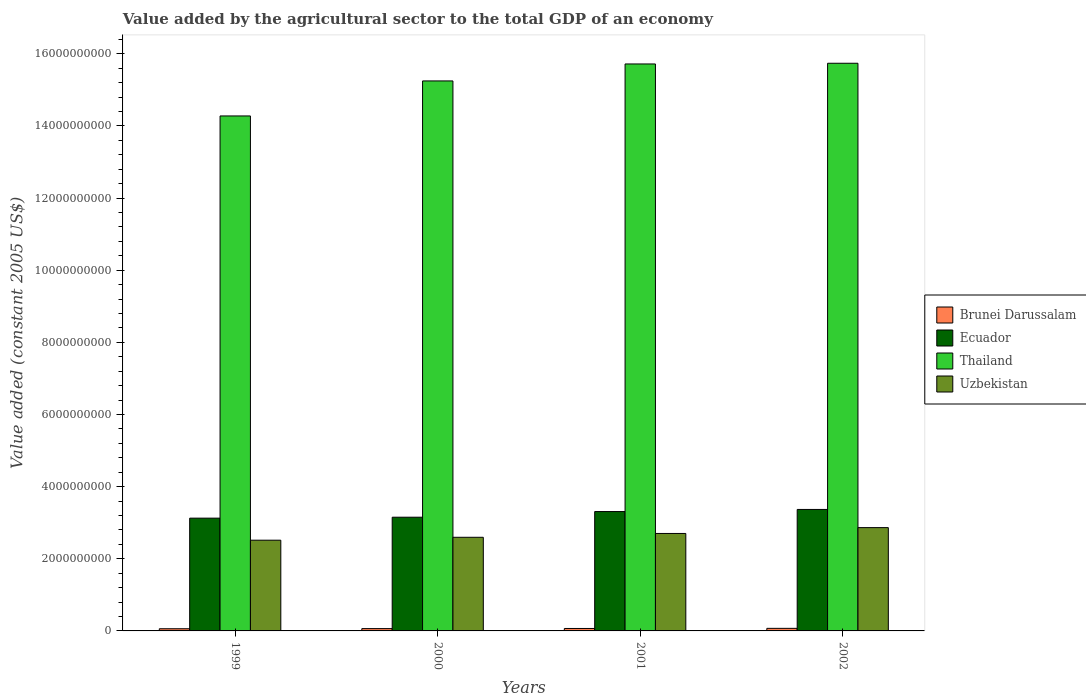How many groups of bars are there?
Make the answer very short. 4. Are the number of bars on each tick of the X-axis equal?
Give a very brief answer. Yes. How many bars are there on the 1st tick from the left?
Provide a succinct answer. 4. How many bars are there on the 2nd tick from the right?
Keep it short and to the point. 4. What is the value added by the agricultural sector in Thailand in 1999?
Give a very brief answer. 1.43e+1. Across all years, what is the maximum value added by the agricultural sector in Thailand?
Ensure brevity in your answer.  1.57e+1. Across all years, what is the minimum value added by the agricultural sector in Ecuador?
Your response must be concise. 3.13e+09. In which year was the value added by the agricultural sector in Uzbekistan maximum?
Ensure brevity in your answer.  2002. What is the total value added by the agricultural sector in Uzbekistan in the graph?
Give a very brief answer. 1.07e+1. What is the difference between the value added by the agricultural sector in Thailand in 2001 and that in 2002?
Your answer should be very brief. -1.94e+07. What is the difference between the value added by the agricultural sector in Brunei Darussalam in 2000 and the value added by the agricultural sector in Uzbekistan in 2001?
Make the answer very short. -2.64e+09. What is the average value added by the agricultural sector in Thailand per year?
Give a very brief answer. 1.52e+1. In the year 2002, what is the difference between the value added by the agricultural sector in Ecuador and value added by the agricultural sector in Brunei Darussalam?
Offer a very short reply. 3.30e+09. What is the ratio of the value added by the agricultural sector in Uzbekistan in 1999 to that in 2002?
Keep it short and to the point. 0.88. Is the value added by the agricultural sector in Brunei Darussalam in 2001 less than that in 2002?
Give a very brief answer. Yes. Is the difference between the value added by the agricultural sector in Ecuador in 2000 and 2002 greater than the difference between the value added by the agricultural sector in Brunei Darussalam in 2000 and 2002?
Make the answer very short. No. What is the difference between the highest and the second highest value added by the agricultural sector in Thailand?
Your answer should be very brief. 1.94e+07. What is the difference between the highest and the lowest value added by the agricultural sector in Thailand?
Your response must be concise. 1.46e+09. In how many years, is the value added by the agricultural sector in Brunei Darussalam greater than the average value added by the agricultural sector in Brunei Darussalam taken over all years?
Your response must be concise. 2. Is the sum of the value added by the agricultural sector in Thailand in 1999 and 2002 greater than the maximum value added by the agricultural sector in Brunei Darussalam across all years?
Offer a very short reply. Yes. What does the 2nd bar from the left in 1999 represents?
Provide a short and direct response. Ecuador. What does the 4th bar from the right in 2000 represents?
Make the answer very short. Brunei Darussalam. Is it the case that in every year, the sum of the value added by the agricultural sector in Brunei Darussalam and value added by the agricultural sector in Thailand is greater than the value added by the agricultural sector in Ecuador?
Your response must be concise. Yes. How many bars are there?
Provide a short and direct response. 16. Are all the bars in the graph horizontal?
Your answer should be compact. No. How many years are there in the graph?
Provide a succinct answer. 4. Does the graph contain grids?
Your response must be concise. No. Where does the legend appear in the graph?
Provide a short and direct response. Center right. How are the legend labels stacked?
Offer a terse response. Vertical. What is the title of the graph?
Provide a short and direct response. Value added by the agricultural sector to the total GDP of an economy. What is the label or title of the X-axis?
Keep it short and to the point. Years. What is the label or title of the Y-axis?
Your response must be concise. Value added (constant 2005 US$). What is the Value added (constant 2005 US$) of Brunei Darussalam in 1999?
Offer a very short reply. 6.02e+07. What is the Value added (constant 2005 US$) in Ecuador in 1999?
Keep it short and to the point. 3.13e+09. What is the Value added (constant 2005 US$) in Thailand in 1999?
Give a very brief answer. 1.43e+1. What is the Value added (constant 2005 US$) in Uzbekistan in 1999?
Your answer should be compact. 2.52e+09. What is the Value added (constant 2005 US$) of Brunei Darussalam in 2000?
Provide a short and direct response. 6.42e+07. What is the Value added (constant 2005 US$) of Ecuador in 2000?
Offer a terse response. 3.15e+09. What is the Value added (constant 2005 US$) of Thailand in 2000?
Your answer should be compact. 1.52e+1. What is the Value added (constant 2005 US$) of Uzbekistan in 2000?
Provide a short and direct response. 2.60e+09. What is the Value added (constant 2005 US$) of Brunei Darussalam in 2001?
Make the answer very short. 6.79e+07. What is the Value added (constant 2005 US$) in Ecuador in 2001?
Offer a very short reply. 3.31e+09. What is the Value added (constant 2005 US$) in Thailand in 2001?
Give a very brief answer. 1.57e+1. What is the Value added (constant 2005 US$) in Uzbekistan in 2001?
Give a very brief answer. 2.70e+09. What is the Value added (constant 2005 US$) of Brunei Darussalam in 2002?
Give a very brief answer. 7.14e+07. What is the Value added (constant 2005 US$) in Ecuador in 2002?
Your answer should be very brief. 3.37e+09. What is the Value added (constant 2005 US$) in Thailand in 2002?
Your answer should be compact. 1.57e+1. What is the Value added (constant 2005 US$) of Uzbekistan in 2002?
Provide a succinct answer. 2.86e+09. Across all years, what is the maximum Value added (constant 2005 US$) of Brunei Darussalam?
Keep it short and to the point. 7.14e+07. Across all years, what is the maximum Value added (constant 2005 US$) in Ecuador?
Your answer should be compact. 3.37e+09. Across all years, what is the maximum Value added (constant 2005 US$) in Thailand?
Make the answer very short. 1.57e+1. Across all years, what is the maximum Value added (constant 2005 US$) in Uzbekistan?
Give a very brief answer. 2.86e+09. Across all years, what is the minimum Value added (constant 2005 US$) in Brunei Darussalam?
Provide a succinct answer. 6.02e+07. Across all years, what is the minimum Value added (constant 2005 US$) of Ecuador?
Ensure brevity in your answer.  3.13e+09. Across all years, what is the minimum Value added (constant 2005 US$) in Thailand?
Give a very brief answer. 1.43e+1. Across all years, what is the minimum Value added (constant 2005 US$) in Uzbekistan?
Offer a terse response. 2.52e+09. What is the total Value added (constant 2005 US$) in Brunei Darussalam in the graph?
Keep it short and to the point. 2.64e+08. What is the total Value added (constant 2005 US$) of Ecuador in the graph?
Your answer should be very brief. 1.30e+1. What is the total Value added (constant 2005 US$) in Thailand in the graph?
Offer a terse response. 6.10e+1. What is the total Value added (constant 2005 US$) in Uzbekistan in the graph?
Offer a very short reply. 1.07e+1. What is the difference between the Value added (constant 2005 US$) in Brunei Darussalam in 1999 and that in 2000?
Your answer should be very brief. -3.95e+06. What is the difference between the Value added (constant 2005 US$) in Ecuador in 1999 and that in 2000?
Your response must be concise. -2.61e+07. What is the difference between the Value added (constant 2005 US$) of Thailand in 1999 and that in 2000?
Give a very brief answer. -9.71e+08. What is the difference between the Value added (constant 2005 US$) in Uzbekistan in 1999 and that in 2000?
Give a very brief answer. -8.05e+07. What is the difference between the Value added (constant 2005 US$) of Brunei Darussalam in 1999 and that in 2001?
Provide a succinct answer. -7.70e+06. What is the difference between the Value added (constant 2005 US$) of Ecuador in 1999 and that in 2001?
Provide a succinct answer. -1.83e+08. What is the difference between the Value added (constant 2005 US$) in Thailand in 1999 and that in 2001?
Make the answer very short. -1.44e+09. What is the difference between the Value added (constant 2005 US$) of Uzbekistan in 1999 and that in 2001?
Offer a very short reply. -1.87e+08. What is the difference between the Value added (constant 2005 US$) of Brunei Darussalam in 1999 and that in 2002?
Your response must be concise. -1.12e+07. What is the difference between the Value added (constant 2005 US$) in Ecuador in 1999 and that in 2002?
Offer a very short reply. -2.41e+08. What is the difference between the Value added (constant 2005 US$) in Thailand in 1999 and that in 2002?
Offer a terse response. -1.46e+09. What is the difference between the Value added (constant 2005 US$) in Uzbekistan in 1999 and that in 2002?
Your answer should be compact. -3.49e+08. What is the difference between the Value added (constant 2005 US$) in Brunei Darussalam in 2000 and that in 2001?
Provide a short and direct response. -3.75e+06. What is the difference between the Value added (constant 2005 US$) of Ecuador in 2000 and that in 2001?
Ensure brevity in your answer.  -1.57e+08. What is the difference between the Value added (constant 2005 US$) in Thailand in 2000 and that in 2001?
Your answer should be very brief. -4.70e+08. What is the difference between the Value added (constant 2005 US$) of Uzbekistan in 2000 and that in 2001?
Offer a very short reply. -1.06e+08. What is the difference between the Value added (constant 2005 US$) in Brunei Darussalam in 2000 and that in 2002?
Provide a short and direct response. -7.27e+06. What is the difference between the Value added (constant 2005 US$) of Ecuador in 2000 and that in 2002?
Keep it short and to the point. -2.15e+08. What is the difference between the Value added (constant 2005 US$) of Thailand in 2000 and that in 2002?
Provide a short and direct response. -4.90e+08. What is the difference between the Value added (constant 2005 US$) in Uzbekistan in 2000 and that in 2002?
Your answer should be compact. -2.69e+08. What is the difference between the Value added (constant 2005 US$) of Brunei Darussalam in 2001 and that in 2002?
Offer a terse response. -3.52e+06. What is the difference between the Value added (constant 2005 US$) of Ecuador in 2001 and that in 2002?
Offer a terse response. -5.85e+07. What is the difference between the Value added (constant 2005 US$) in Thailand in 2001 and that in 2002?
Your answer should be very brief. -1.94e+07. What is the difference between the Value added (constant 2005 US$) of Uzbekistan in 2001 and that in 2002?
Ensure brevity in your answer.  -1.62e+08. What is the difference between the Value added (constant 2005 US$) in Brunei Darussalam in 1999 and the Value added (constant 2005 US$) in Ecuador in 2000?
Give a very brief answer. -3.09e+09. What is the difference between the Value added (constant 2005 US$) of Brunei Darussalam in 1999 and the Value added (constant 2005 US$) of Thailand in 2000?
Offer a terse response. -1.52e+1. What is the difference between the Value added (constant 2005 US$) of Brunei Darussalam in 1999 and the Value added (constant 2005 US$) of Uzbekistan in 2000?
Make the answer very short. -2.54e+09. What is the difference between the Value added (constant 2005 US$) in Ecuador in 1999 and the Value added (constant 2005 US$) in Thailand in 2000?
Keep it short and to the point. -1.21e+1. What is the difference between the Value added (constant 2005 US$) in Ecuador in 1999 and the Value added (constant 2005 US$) in Uzbekistan in 2000?
Your answer should be compact. 5.31e+08. What is the difference between the Value added (constant 2005 US$) of Thailand in 1999 and the Value added (constant 2005 US$) of Uzbekistan in 2000?
Your response must be concise. 1.17e+1. What is the difference between the Value added (constant 2005 US$) of Brunei Darussalam in 1999 and the Value added (constant 2005 US$) of Ecuador in 2001?
Your answer should be very brief. -3.25e+09. What is the difference between the Value added (constant 2005 US$) of Brunei Darussalam in 1999 and the Value added (constant 2005 US$) of Thailand in 2001?
Keep it short and to the point. -1.57e+1. What is the difference between the Value added (constant 2005 US$) of Brunei Darussalam in 1999 and the Value added (constant 2005 US$) of Uzbekistan in 2001?
Ensure brevity in your answer.  -2.64e+09. What is the difference between the Value added (constant 2005 US$) in Ecuador in 1999 and the Value added (constant 2005 US$) in Thailand in 2001?
Offer a terse response. -1.26e+1. What is the difference between the Value added (constant 2005 US$) in Ecuador in 1999 and the Value added (constant 2005 US$) in Uzbekistan in 2001?
Your response must be concise. 4.24e+08. What is the difference between the Value added (constant 2005 US$) of Thailand in 1999 and the Value added (constant 2005 US$) of Uzbekistan in 2001?
Your answer should be compact. 1.16e+1. What is the difference between the Value added (constant 2005 US$) in Brunei Darussalam in 1999 and the Value added (constant 2005 US$) in Ecuador in 2002?
Offer a terse response. -3.31e+09. What is the difference between the Value added (constant 2005 US$) in Brunei Darussalam in 1999 and the Value added (constant 2005 US$) in Thailand in 2002?
Offer a very short reply. -1.57e+1. What is the difference between the Value added (constant 2005 US$) of Brunei Darussalam in 1999 and the Value added (constant 2005 US$) of Uzbekistan in 2002?
Keep it short and to the point. -2.80e+09. What is the difference between the Value added (constant 2005 US$) in Ecuador in 1999 and the Value added (constant 2005 US$) in Thailand in 2002?
Provide a short and direct response. -1.26e+1. What is the difference between the Value added (constant 2005 US$) of Ecuador in 1999 and the Value added (constant 2005 US$) of Uzbekistan in 2002?
Make the answer very short. 2.62e+08. What is the difference between the Value added (constant 2005 US$) in Thailand in 1999 and the Value added (constant 2005 US$) in Uzbekistan in 2002?
Make the answer very short. 1.14e+1. What is the difference between the Value added (constant 2005 US$) in Brunei Darussalam in 2000 and the Value added (constant 2005 US$) in Ecuador in 2001?
Keep it short and to the point. -3.25e+09. What is the difference between the Value added (constant 2005 US$) in Brunei Darussalam in 2000 and the Value added (constant 2005 US$) in Thailand in 2001?
Offer a very short reply. -1.57e+1. What is the difference between the Value added (constant 2005 US$) of Brunei Darussalam in 2000 and the Value added (constant 2005 US$) of Uzbekistan in 2001?
Your answer should be very brief. -2.64e+09. What is the difference between the Value added (constant 2005 US$) of Ecuador in 2000 and the Value added (constant 2005 US$) of Thailand in 2001?
Make the answer very short. -1.26e+1. What is the difference between the Value added (constant 2005 US$) of Ecuador in 2000 and the Value added (constant 2005 US$) of Uzbekistan in 2001?
Ensure brevity in your answer.  4.51e+08. What is the difference between the Value added (constant 2005 US$) in Thailand in 2000 and the Value added (constant 2005 US$) in Uzbekistan in 2001?
Give a very brief answer. 1.25e+1. What is the difference between the Value added (constant 2005 US$) of Brunei Darussalam in 2000 and the Value added (constant 2005 US$) of Ecuador in 2002?
Ensure brevity in your answer.  -3.30e+09. What is the difference between the Value added (constant 2005 US$) of Brunei Darussalam in 2000 and the Value added (constant 2005 US$) of Thailand in 2002?
Offer a terse response. -1.57e+1. What is the difference between the Value added (constant 2005 US$) in Brunei Darussalam in 2000 and the Value added (constant 2005 US$) in Uzbekistan in 2002?
Keep it short and to the point. -2.80e+09. What is the difference between the Value added (constant 2005 US$) in Ecuador in 2000 and the Value added (constant 2005 US$) in Thailand in 2002?
Offer a very short reply. -1.26e+1. What is the difference between the Value added (constant 2005 US$) in Ecuador in 2000 and the Value added (constant 2005 US$) in Uzbekistan in 2002?
Your answer should be very brief. 2.88e+08. What is the difference between the Value added (constant 2005 US$) of Thailand in 2000 and the Value added (constant 2005 US$) of Uzbekistan in 2002?
Your answer should be very brief. 1.24e+1. What is the difference between the Value added (constant 2005 US$) of Brunei Darussalam in 2001 and the Value added (constant 2005 US$) of Ecuador in 2002?
Provide a short and direct response. -3.30e+09. What is the difference between the Value added (constant 2005 US$) in Brunei Darussalam in 2001 and the Value added (constant 2005 US$) in Thailand in 2002?
Give a very brief answer. -1.57e+1. What is the difference between the Value added (constant 2005 US$) in Brunei Darussalam in 2001 and the Value added (constant 2005 US$) in Uzbekistan in 2002?
Ensure brevity in your answer.  -2.80e+09. What is the difference between the Value added (constant 2005 US$) of Ecuador in 2001 and the Value added (constant 2005 US$) of Thailand in 2002?
Offer a terse response. -1.24e+1. What is the difference between the Value added (constant 2005 US$) in Ecuador in 2001 and the Value added (constant 2005 US$) in Uzbekistan in 2002?
Provide a short and direct response. 4.45e+08. What is the difference between the Value added (constant 2005 US$) of Thailand in 2001 and the Value added (constant 2005 US$) of Uzbekistan in 2002?
Make the answer very short. 1.29e+1. What is the average Value added (constant 2005 US$) in Brunei Darussalam per year?
Provide a short and direct response. 6.59e+07. What is the average Value added (constant 2005 US$) in Ecuador per year?
Your response must be concise. 3.24e+09. What is the average Value added (constant 2005 US$) of Thailand per year?
Provide a short and direct response. 1.52e+1. What is the average Value added (constant 2005 US$) of Uzbekistan per year?
Offer a terse response. 2.67e+09. In the year 1999, what is the difference between the Value added (constant 2005 US$) of Brunei Darussalam and Value added (constant 2005 US$) of Ecuador?
Your answer should be compact. -3.07e+09. In the year 1999, what is the difference between the Value added (constant 2005 US$) in Brunei Darussalam and Value added (constant 2005 US$) in Thailand?
Keep it short and to the point. -1.42e+1. In the year 1999, what is the difference between the Value added (constant 2005 US$) in Brunei Darussalam and Value added (constant 2005 US$) in Uzbekistan?
Make the answer very short. -2.46e+09. In the year 1999, what is the difference between the Value added (constant 2005 US$) in Ecuador and Value added (constant 2005 US$) in Thailand?
Keep it short and to the point. -1.12e+1. In the year 1999, what is the difference between the Value added (constant 2005 US$) in Ecuador and Value added (constant 2005 US$) in Uzbekistan?
Ensure brevity in your answer.  6.11e+08. In the year 1999, what is the difference between the Value added (constant 2005 US$) in Thailand and Value added (constant 2005 US$) in Uzbekistan?
Keep it short and to the point. 1.18e+1. In the year 2000, what is the difference between the Value added (constant 2005 US$) in Brunei Darussalam and Value added (constant 2005 US$) in Ecuador?
Provide a short and direct response. -3.09e+09. In the year 2000, what is the difference between the Value added (constant 2005 US$) of Brunei Darussalam and Value added (constant 2005 US$) of Thailand?
Offer a very short reply. -1.52e+1. In the year 2000, what is the difference between the Value added (constant 2005 US$) of Brunei Darussalam and Value added (constant 2005 US$) of Uzbekistan?
Your answer should be compact. -2.53e+09. In the year 2000, what is the difference between the Value added (constant 2005 US$) in Ecuador and Value added (constant 2005 US$) in Thailand?
Offer a terse response. -1.21e+1. In the year 2000, what is the difference between the Value added (constant 2005 US$) in Ecuador and Value added (constant 2005 US$) in Uzbekistan?
Offer a terse response. 5.57e+08. In the year 2000, what is the difference between the Value added (constant 2005 US$) of Thailand and Value added (constant 2005 US$) of Uzbekistan?
Provide a succinct answer. 1.27e+1. In the year 2001, what is the difference between the Value added (constant 2005 US$) of Brunei Darussalam and Value added (constant 2005 US$) of Ecuador?
Provide a short and direct response. -3.24e+09. In the year 2001, what is the difference between the Value added (constant 2005 US$) of Brunei Darussalam and Value added (constant 2005 US$) of Thailand?
Provide a succinct answer. -1.57e+1. In the year 2001, what is the difference between the Value added (constant 2005 US$) in Brunei Darussalam and Value added (constant 2005 US$) in Uzbekistan?
Provide a succinct answer. -2.63e+09. In the year 2001, what is the difference between the Value added (constant 2005 US$) of Ecuador and Value added (constant 2005 US$) of Thailand?
Your response must be concise. -1.24e+1. In the year 2001, what is the difference between the Value added (constant 2005 US$) in Ecuador and Value added (constant 2005 US$) in Uzbekistan?
Keep it short and to the point. 6.07e+08. In the year 2001, what is the difference between the Value added (constant 2005 US$) in Thailand and Value added (constant 2005 US$) in Uzbekistan?
Ensure brevity in your answer.  1.30e+1. In the year 2002, what is the difference between the Value added (constant 2005 US$) of Brunei Darussalam and Value added (constant 2005 US$) of Ecuador?
Your answer should be very brief. -3.30e+09. In the year 2002, what is the difference between the Value added (constant 2005 US$) in Brunei Darussalam and Value added (constant 2005 US$) in Thailand?
Keep it short and to the point. -1.57e+1. In the year 2002, what is the difference between the Value added (constant 2005 US$) in Brunei Darussalam and Value added (constant 2005 US$) in Uzbekistan?
Your answer should be very brief. -2.79e+09. In the year 2002, what is the difference between the Value added (constant 2005 US$) in Ecuador and Value added (constant 2005 US$) in Thailand?
Your response must be concise. -1.24e+1. In the year 2002, what is the difference between the Value added (constant 2005 US$) of Ecuador and Value added (constant 2005 US$) of Uzbekistan?
Offer a terse response. 5.03e+08. In the year 2002, what is the difference between the Value added (constant 2005 US$) in Thailand and Value added (constant 2005 US$) in Uzbekistan?
Give a very brief answer. 1.29e+1. What is the ratio of the Value added (constant 2005 US$) in Brunei Darussalam in 1999 to that in 2000?
Give a very brief answer. 0.94. What is the ratio of the Value added (constant 2005 US$) in Thailand in 1999 to that in 2000?
Make the answer very short. 0.94. What is the ratio of the Value added (constant 2005 US$) of Uzbekistan in 1999 to that in 2000?
Offer a very short reply. 0.97. What is the ratio of the Value added (constant 2005 US$) in Brunei Darussalam in 1999 to that in 2001?
Your answer should be very brief. 0.89. What is the ratio of the Value added (constant 2005 US$) in Ecuador in 1999 to that in 2001?
Your answer should be very brief. 0.94. What is the ratio of the Value added (constant 2005 US$) of Thailand in 1999 to that in 2001?
Ensure brevity in your answer.  0.91. What is the ratio of the Value added (constant 2005 US$) of Uzbekistan in 1999 to that in 2001?
Your answer should be compact. 0.93. What is the ratio of the Value added (constant 2005 US$) of Brunei Darussalam in 1999 to that in 2002?
Your response must be concise. 0.84. What is the ratio of the Value added (constant 2005 US$) of Ecuador in 1999 to that in 2002?
Ensure brevity in your answer.  0.93. What is the ratio of the Value added (constant 2005 US$) in Thailand in 1999 to that in 2002?
Your answer should be very brief. 0.91. What is the ratio of the Value added (constant 2005 US$) in Uzbekistan in 1999 to that in 2002?
Ensure brevity in your answer.  0.88. What is the ratio of the Value added (constant 2005 US$) of Brunei Darussalam in 2000 to that in 2001?
Provide a short and direct response. 0.94. What is the ratio of the Value added (constant 2005 US$) of Ecuador in 2000 to that in 2001?
Keep it short and to the point. 0.95. What is the ratio of the Value added (constant 2005 US$) of Thailand in 2000 to that in 2001?
Provide a short and direct response. 0.97. What is the ratio of the Value added (constant 2005 US$) in Uzbekistan in 2000 to that in 2001?
Provide a succinct answer. 0.96. What is the ratio of the Value added (constant 2005 US$) of Brunei Darussalam in 2000 to that in 2002?
Offer a very short reply. 0.9. What is the ratio of the Value added (constant 2005 US$) of Ecuador in 2000 to that in 2002?
Provide a short and direct response. 0.94. What is the ratio of the Value added (constant 2005 US$) in Thailand in 2000 to that in 2002?
Your answer should be very brief. 0.97. What is the ratio of the Value added (constant 2005 US$) in Uzbekistan in 2000 to that in 2002?
Offer a very short reply. 0.91. What is the ratio of the Value added (constant 2005 US$) in Brunei Darussalam in 2001 to that in 2002?
Provide a short and direct response. 0.95. What is the ratio of the Value added (constant 2005 US$) in Ecuador in 2001 to that in 2002?
Offer a terse response. 0.98. What is the ratio of the Value added (constant 2005 US$) in Uzbekistan in 2001 to that in 2002?
Provide a short and direct response. 0.94. What is the difference between the highest and the second highest Value added (constant 2005 US$) of Brunei Darussalam?
Your response must be concise. 3.52e+06. What is the difference between the highest and the second highest Value added (constant 2005 US$) of Ecuador?
Make the answer very short. 5.85e+07. What is the difference between the highest and the second highest Value added (constant 2005 US$) of Thailand?
Give a very brief answer. 1.94e+07. What is the difference between the highest and the second highest Value added (constant 2005 US$) in Uzbekistan?
Provide a short and direct response. 1.62e+08. What is the difference between the highest and the lowest Value added (constant 2005 US$) in Brunei Darussalam?
Provide a short and direct response. 1.12e+07. What is the difference between the highest and the lowest Value added (constant 2005 US$) in Ecuador?
Provide a succinct answer. 2.41e+08. What is the difference between the highest and the lowest Value added (constant 2005 US$) of Thailand?
Your answer should be compact. 1.46e+09. What is the difference between the highest and the lowest Value added (constant 2005 US$) in Uzbekistan?
Your response must be concise. 3.49e+08. 